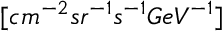<formula> <loc_0><loc_0><loc_500><loc_500>[ c m ^ { - 2 } s r ^ { - 1 } s ^ { - 1 } G e V ^ { - 1 } ]</formula> 